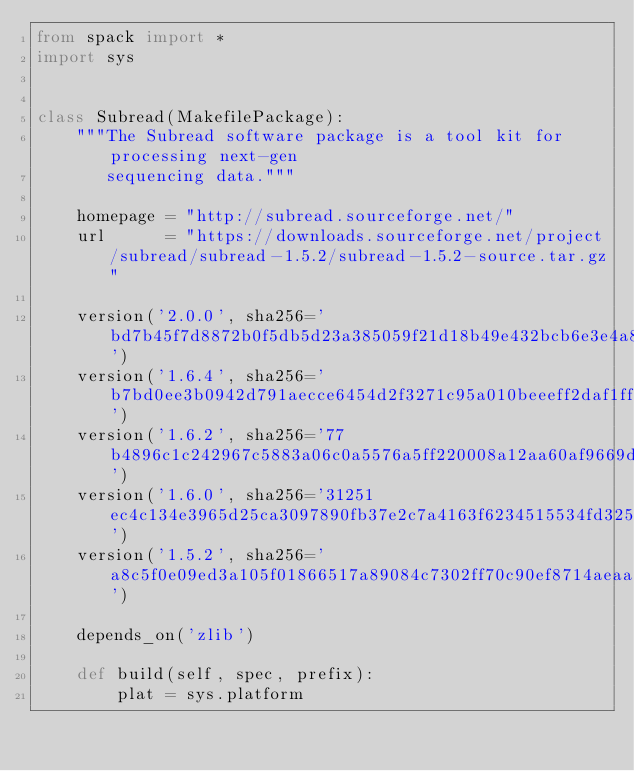<code> <loc_0><loc_0><loc_500><loc_500><_Python_>from spack import *
import sys


class Subread(MakefilePackage):
    """The Subread software package is a tool kit for processing next-gen
       sequencing data."""

    homepage = "http://subread.sourceforge.net/"
    url      = "https://downloads.sourceforge.net/project/subread/subread-1.5.2/subread-1.5.2-source.tar.gz"

    version('2.0.0', sha256='bd7b45f7d8872b0f5db5d23a385059f21d18b49e432bcb6e3e4a879fe51b41a8')
    version('1.6.4', sha256='b7bd0ee3b0942d791aecce6454d2f3271c95a010beeeff2daf1ff71162e43969')
    version('1.6.2', sha256='77b4896c1c242967c5883a06c0a5576a5ff220008a12aa60af9669d2f9a87d7a')
    version('1.6.0', sha256='31251ec4c134e3965d25ca3097890fb37e2c7a4163f6234515534fd325b1002a')
    version('1.5.2', sha256='a8c5f0e09ed3a105f01866517a89084c7302ff70c90ef8714aeaa2eab181a0aa')

    depends_on('zlib')

    def build(self, spec, prefix):
        plat = sys.platform</code> 